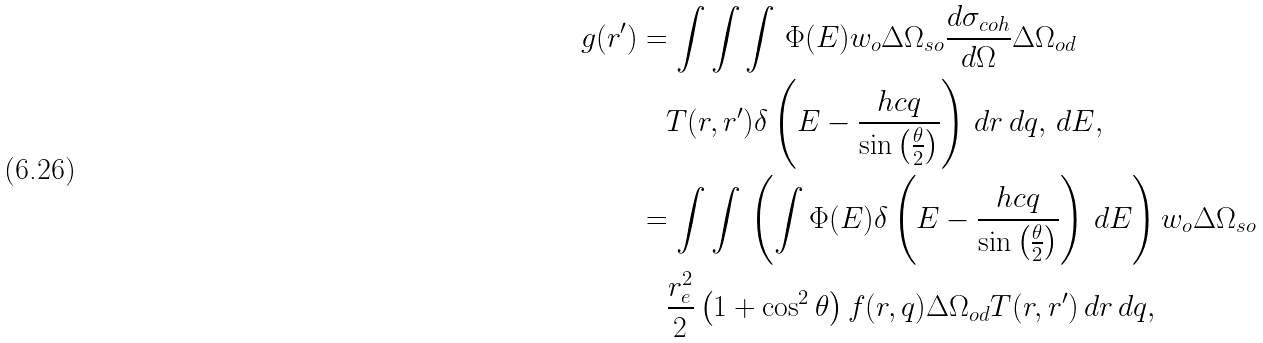<formula> <loc_0><loc_0><loc_500><loc_500>g ( r ^ { \prime } ) & = \int \int \int \, \Phi ( E ) w _ { o } \Delta \Omega _ { s o } \frac { d \sigma _ { c o h } } { d \Omega } \Delta \Omega _ { o d } \\ & \quad T ( r , r ^ { \prime } ) \delta \left ( E - \frac { h c q } { \sin \left ( \frac { \theta } { 2 } \right ) } \right ) \, d r \, d q , \, d E , \\ & = \int \int \, \left ( \int \Phi ( E ) \delta \left ( E - \frac { h c q } { \sin \left ( \frac { \theta } { 2 } \right ) } \right ) \, d E \right ) w _ { o } \Delta \Omega _ { s o } \\ & \quad \frac { r _ { e } ^ { 2 } } { 2 } \left ( 1 + \cos ^ { 2 } \theta \right ) f ( r , q ) \Delta \Omega _ { o d } T ( r , r ^ { \prime } ) \, d r \, d q ,</formula> 